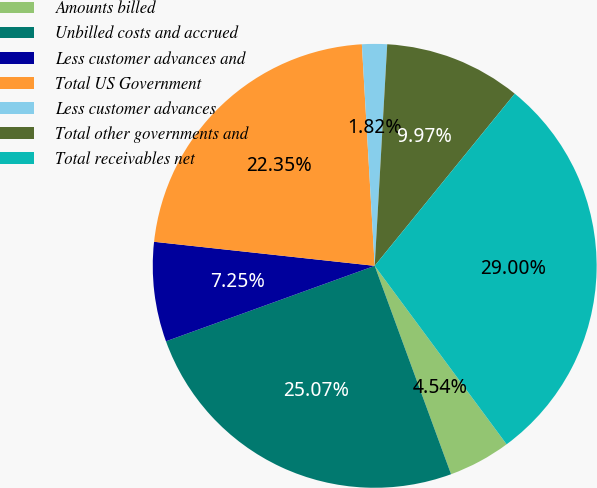<chart> <loc_0><loc_0><loc_500><loc_500><pie_chart><fcel>Amounts billed<fcel>Unbilled costs and accrued<fcel>Less customer advances and<fcel>Total US Government<fcel>Less customer advances<fcel>Total other governments and<fcel>Total receivables net<nl><fcel>4.54%<fcel>25.07%<fcel>7.25%<fcel>22.35%<fcel>1.82%<fcel>9.97%<fcel>29.0%<nl></chart> 